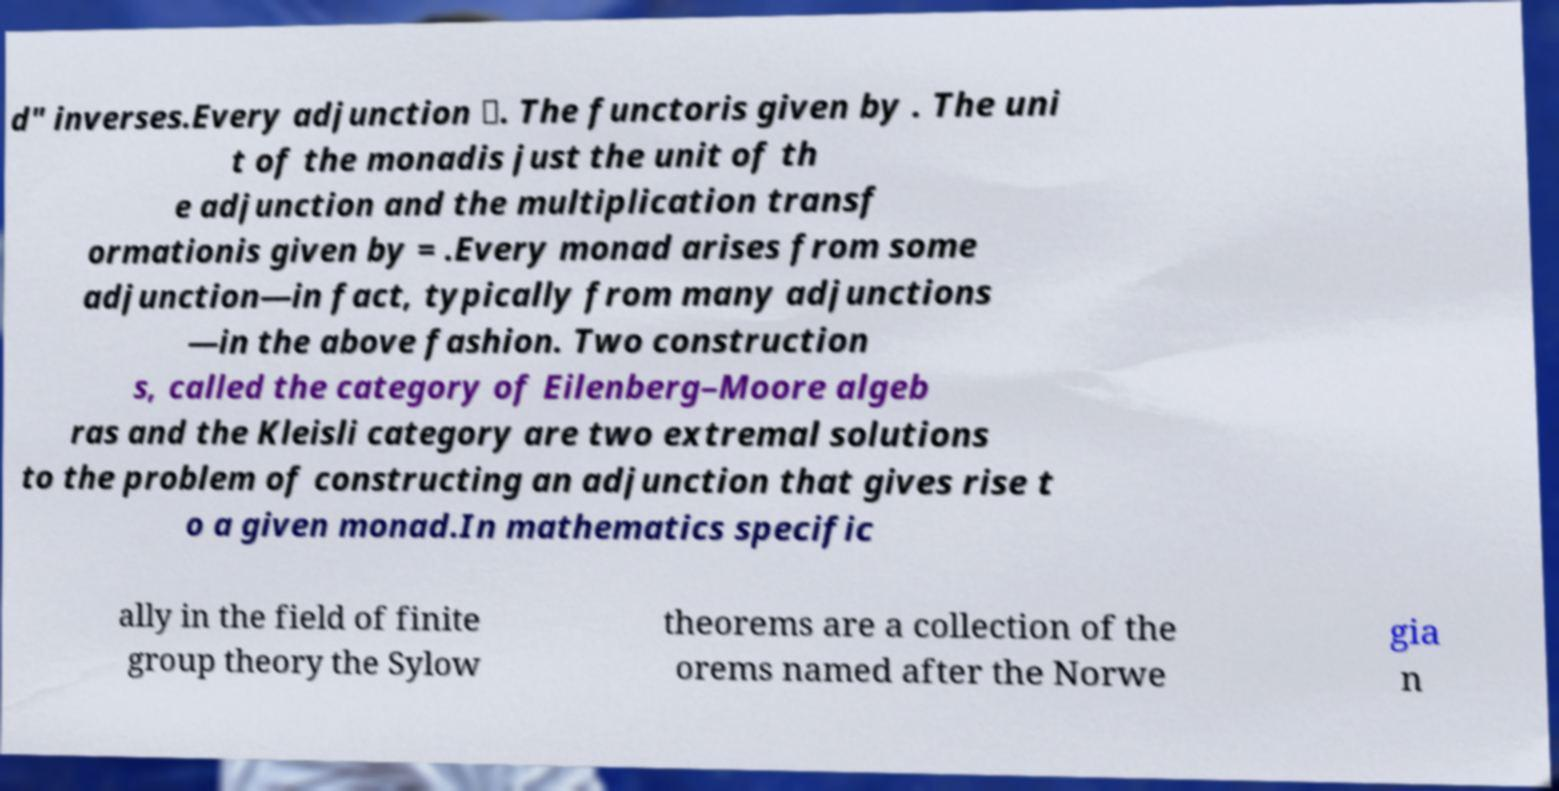Can you accurately transcribe the text from the provided image for me? d" inverses.Every adjunction 〈. The functoris given by . The uni t of the monadis just the unit of th e adjunction and the multiplication transf ormationis given by = .Every monad arises from some adjunction—in fact, typically from many adjunctions —in the above fashion. Two construction s, called the category of Eilenberg–Moore algeb ras and the Kleisli category are two extremal solutions to the problem of constructing an adjunction that gives rise t o a given monad.In mathematics specific ally in the field of finite group theory the Sylow theorems are a collection of the orems named after the Norwe gia n 